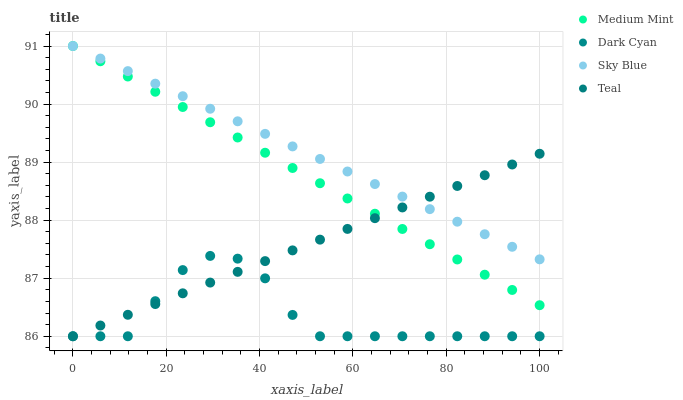Does Dark Cyan have the minimum area under the curve?
Answer yes or no. Yes. Does Sky Blue have the maximum area under the curve?
Answer yes or no. Yes. Does Teal have the minimum area under the curve?
Answer yes or no. No. Does Teal have the maximum area under the curve?
Answer yes or no. No. Is Teal the smoothest?
Answer yes or no. Yes. Is Dark Cyan the roughest?
Answer yes or no. Yes. Is Dark Cyan the smoothest?
Answer yes or no. No. Is Teal the roughest?
Answer yes or no. No. Does Dark Cyan have the lowest value?
Answer yes or no. Yes. Does Sky Blue have the lowest value?
Answer yes or no. No. Does Sky Blue have the highest value?
Answer yes or no. Yes. Does Teal have the highest value?
Answer yes or no. No. Is Dark Cyan less than Medium Mint?
Answer yes or no. Yes. Is Sky Blue greater than Dark Cyan?
Answer yes or no. Yes. Does Teal intersect Sky Blue?
Answer yes or no. Yes. Is Teal less than Sky Blue?
Answer yes or no. No. Is Teal greater than Sky Blue?
Answer yes or no. No. Does Dark Cyan intersect Medium Mint?
Answer yes or no. No. 